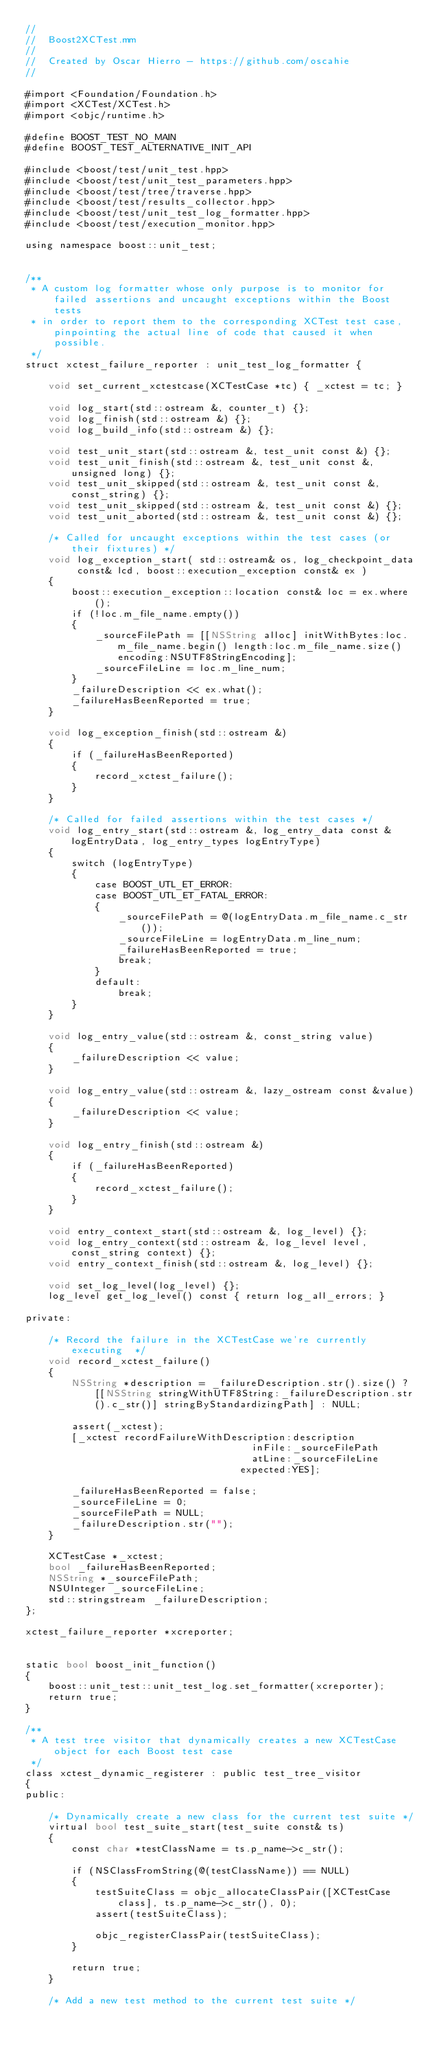<code> <loc_0><loc_0><loc_500><loc_500><_ObjectiveC_>//
//  Boost2XCTest.mm
//
//  Created by Oscar Hierro - https://github.com/oscahie
//

#import <Foundation/Foundation.h>
#import <XCTest/XCTest.h>
#import <objc/runtime.h>

#define BOOST_TEST_NO_MAIN
#define BOOST_TEST_ALTERNATIVE_INIT_API

#include <boost/test/unit_test.hpp>
#include <boost/test/unit_test_parameters.hpp>
#include <boost/test/tree/traverse.hpp>
#include <boost/test/results_collector.hpp>
#include <boost/test/unit_test_log_formatter.hpp>
#include <boost/test/execution_monitor.hpp>

using namespace boost::unit_test;


/**
 * A custom log formatter whose only purpose is to monitor for failed assertions and uncaught exceptions within the Boost tests
 * in order to report them to the corresponding XCTest test case, pinpointing the actual line of code that caused it when possible.
 */
struct xctest_failure_reporter : unit_test_log_formatter {
    
    void set_current_xctestcase(XCTestCase *tc) { _xctest = tc; }
    
    void log_start(std::ostream &, counter_t) {};
    void log_finish(std::ostream &) {};
    void log_build_info(std::ostream &) {};
    
    void test_unit_start(std::ostream &, test_unit const &) {};
    void test_unit_finish(std::ostream &, test_unit const &, unsigned long) {};
    void test_unit_skipped(std::ostream &, test_unit const &, const_string) {};
    void test_unit_skipped(std::ostream &, test_unit const &) {};
    void test_unit_aborted(std::ostream &, test_unit const &) {};

    /* Called for uncaught exceptions within the test cases (or their fixtures) */
    void log_exception_start( std::ostream& os, log_checkpoint_data const& lcd, boost::execution_exception const& ex )
    {
        boost::execution_exception::location const& loc = ex.where();
        if (!loc.m_file_name.empty())
        {
            _sourceFilePath = [[NSString alloc] initWithBytes:loc.m_file_name.begin() length:loc.m_file_name.size() encoding:NSUTF8StringEncoding];
            _sourceFileLine = loc.m_line_num;
        }
        _failureDescription << ex.what();
        _failureHasBeenReported = true;
    }
    
    void log_exception_finish(std::ostream &)
    {
        if (_failureHasBeenReported)
        {
            record_xctest_failure();
        }
    }

    /* Called for failed assertions within the test cases */
    void log_entry_start(std::ostream &, log_entry_data const &logEntryData, log_entry_types logEntryType)
    {
        switch (logEntryType)
        {
            case BOOST_UTL_ET_ERROR:
            case BOOST_UTL_ET_FATAL_ERROR:
            {
                _sourceFilePath = @(logEntryData.m_file_name.c_str());
                _sourceFileLine = logEntryData.m_line_num;
                _failureHasBeenReported = true;
                break;
            }
            default:
                break;
        }
    }

    void log_entry_value(std::ostream &, const_string value)
    {
        _failureDescription << value;
    }

    void log_entry_value(std::ostream &, lazy_ostream const &value)
    {
        _failureDescription << value;
    }

    void log_entry_finish(std::ostream &)
    {
        if (_failureHasBeenReported)
        {
            record_xctest_failure();
        }
    }

    void entry_context_start(std::ostream &, log_level) {};
    void log_entry_context(std::ostream &, log_level level, const_string context) {};
    void entry_context_finish(std::ostream &, log_level) {};

    void set_log_level(log_level) {};
    log_level get_log_level() const { return log_all_errors; }

private:

    /* Record the failure in the XCTestCase we're currently executing  */
    void record_xctest_failure()
    {
        NSString *description = _failureDescription.str().size() ? [[NSString stringWithUTF8String:_failureDescription.str().c_str()] stringByStandardizingPath] : NULL;

        assert(_xctest);
        [_xctest recordFailureWithDescription:description
                                       inFile:_sourceFilePath
                                       atLine:_sourceFileLine
                                     expected:YES];

        _failureHasBeenReported = false;
        _sourceFileLine = 0;
        _sourceFilePath = NULL;
        _failureDescription.str("");
    }

    XCTestCase *_xctest;
    bool _failureHasBeenReported;
    NSString *_sourceFilePath;
    NSUInteger _sourceFileLine;
    std::stringstream _failureDescription;
};

xctest_failure_reporter *xcreporter;


static bool boost_init_function()
{
    boost::unit_test::unit_test_log.set_formatter(xcreporter);
    return true;
}

/**
 * A test tree visitor that dynamically creates a new XCTestCase object for each Boost test case
 */
class xctest_dynamic_registerer : public test_tree_visitor
{
public:

    /* Dynamically create a new class for the current test suite */
    virtual bool test_suite_start(test_suite const& ts)
    {
        const char *testClassName = ts.p_name->c_str();

        if (NSClassFromString(@(testClassName)) == NULL)
        {
            testSuiteClass = objc_allocateClassPair([XCTestCase class], ts.p_name->c_str(), 0);
            assert(testSuiteClass);

            objc_registerClassPair(testSuiteClass);
        }

        return true;
    }

    /* Add a new test method to the current test suite */</code> 